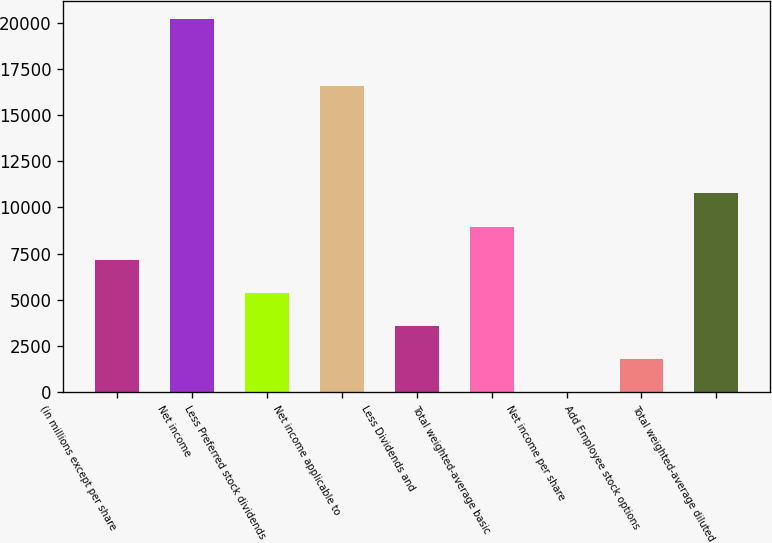Convert chart. <chart><loc_0><loc_0><loc_500><loc_500><bar_chart><fcel>(in millions except per share<fcel>Net income<fcel>Less Preferred stock dividends<fcel>Net income applicable to<fcel>Less Dividends and<fcel>Total weighted-average basic<fcel>Net income per share<fcel>Add Employee stock options<fcel>Total weighted-average diluted<nl><fcel>7171.83<fcel>20176.7<fcel>5379.97<fcel>16593<fcel>3588.11<fcel>8963.69<fcel>4.39<fcel>1796.25<fcel>10755.5<nl></chart> 